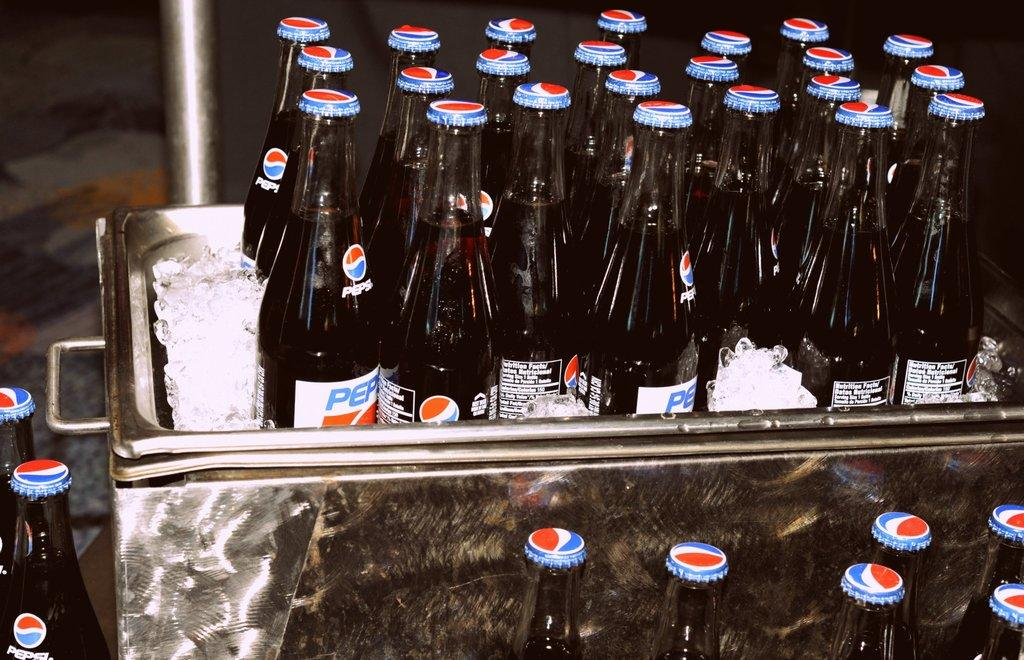Provide a one-sentence caption for the provided image. Old fashioned pepsi's in the bottles with the screw off lids sitting in a silver cooler on ice. 